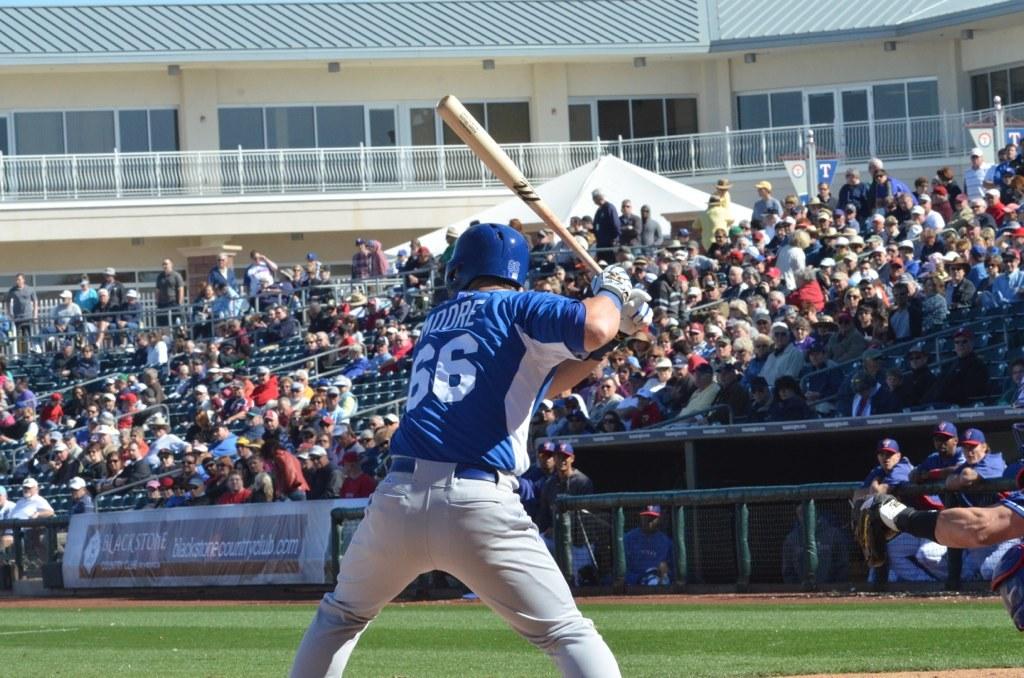What name is on the back of the jersey?
Ensure brevity in your answer.  Moore. 